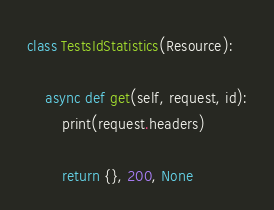<code> <loc_0><loc_0><loc_500><loc_500><_Python_>
class TestsIdStatistics(Resource):

    async def get(self, request, id):
        print(request.headers)

        return {}, 200, None</code> 